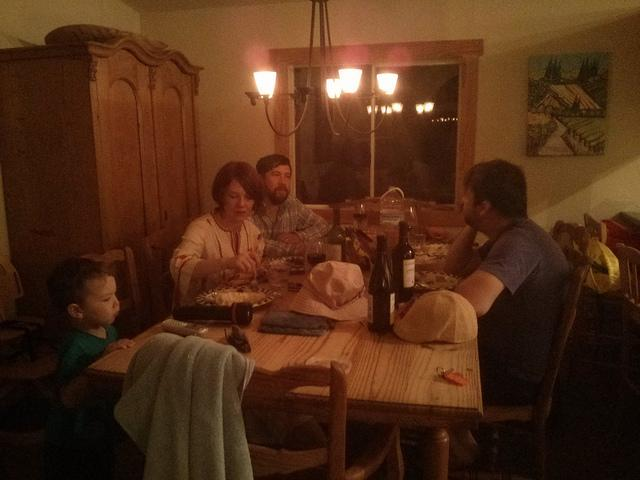Where are these people gathered?

Choices:
A) hospital
B) home
C) museum
D) restaurant home 